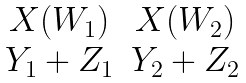<formula> <loc_0><loc_0><loc_500><loc_500>\begin{matrix} X ( W _ { 1 } ) & X ( W _ { 2 } ) \\ Y _ { 1 } + Z _ { 1 } & Y _ { 2 } + Z _ { 2 } \end{matrix}</formula> 